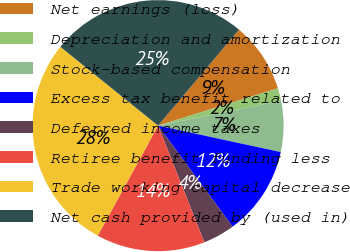Convert chart. <chart><loc_0><loc_0><loc_500><loc_500><pie_chart><fcel>Net earnings (loss)<fcel>Depreciation and amortization<fcel>Stock-based compensation<fcel>Excess tax benefit related to<fcel>Deferred income taxes<fcel>Retiree benefit funding less<fcel>Trade working capital decrease<fcel>Net cash provided by (used in)<nl><fcel>9.04%<fcel>1.62%<fcel>6.57%<fcel>11.51%<fcel>4.1%<fcel>13.99%<fcel>27.82%<fcel>25.35%<nl></chart> 